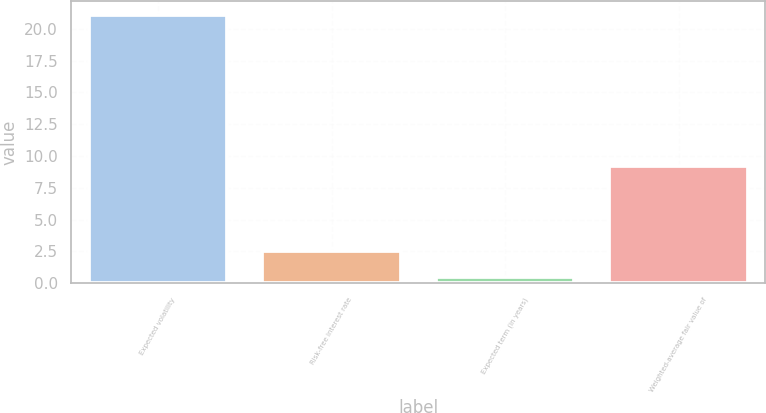Convert chart to OTSL. <chart><loc_0><loc_0><loc_500><loc_500><bar_chart><fcel>Expected volatility<fcel>Risk-free interest rate<fcel>Expected term (in years)<fcel>Weighted-average fair value of<nl><fcel>21.1<fcel>2.56<fcel>0.5<fcel>9.24<nl></chart> 